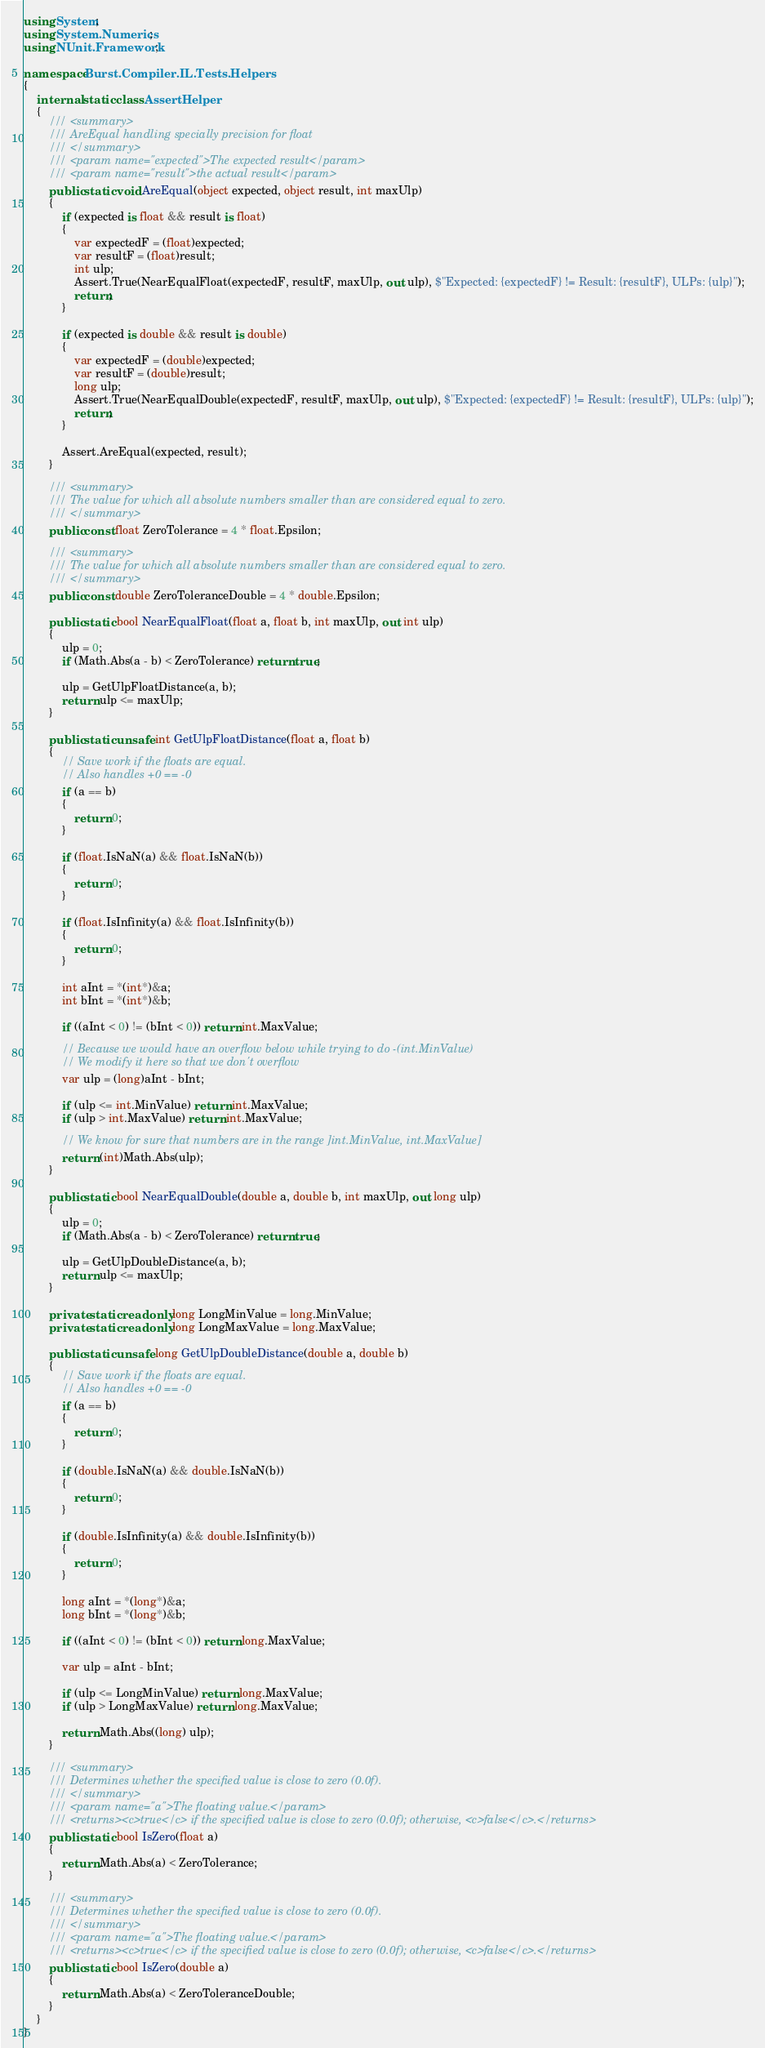<code> <loc_0><loc_0><loc_500><loc_500><_C#_>using System;
using System.Numerics;
using NUnit.Framework;

namespace Burst.Compiler.IL.Tests.Helpers
{
    internal static class AssertHelper
    {
        /// <summary>
        /// AreEqual handling specially precision for float
        /// </summary>
        /// <param name="expected">The expected result</param>
        /// <param name="result">the actual result</param>
        public static void AreEqual(object expected, object result, int maxUlp)
        {
            if (expected is float && result is float)
            {
                var expectedF = (float)expected;
                var resultF = (float)result;
                int ulp;
                Assert.True(NearEqualFloat(expectedF, resultF, maxUlp, out ulp), $"Expected: {expectedF} != Result: {resultF}, ULPs: {ulp}");
                return;
            }

            if (expected is double && result is double)
            {
                var expectedF = (double)expected;
                var resultF = (double)result;
                long ulp;
                Assert.True(NearEqualDouble(expectedF, resultF, maxUlp, out ulp), $"Expected: {expectedF} != Result: {resultF}, ULPs: {ulp}");
                return;
            }

            Assert.AreEqual(expected, result);
        }

        /// <summary>
        /// The value for which all absolute numbers smaller than are considered equal to zero.
        /// </summary>
        public const float ZeroTolerance = 4 * float.Epsilon;

        /// <summary>
        /// The value for which all absolute numbers smaller than are considered equal to zero.
        /// </summary>
        public const double ZeroToleranceDouble = 4 * double.Epsilon;

        public static bool NearEqualFloat(float a, float b, int maxUlp, out int ulp)
        {
            ulp = 0;
            if (Math.Abs(a - b) < ZeroTolerance) return true;

            ulp = GetUlpFloatDistance(a, b);
            return ulp <= maxUlp;
        }

        public static unsafe int GetUlpFloatDistance(float a, float b)
        {
            // Save work if the floats are equal.
            // Also handles +0 == -0
            if (a == b)
            {
                return 0;
            }

            if (float.IsNaN(a) && float.IsNaN(b))
            {
                return 0;
            }

            if (float.IsInfinity(a) && float.IsInfinity(b))
            {
                return 0;
            }

            int aInt = *(int*)&a;
            int bInt = *(int*)&b;

            if ((aInt < 0) != (bInt < 0)) return int.MaxValue;

            // Because we would have an overflow below while trying to do -(int.MinValue)
            // We modify it here so that we don't overflow
            var ulp = (long)aInt - bInt;

            if (ulp <= int.MinValue) return int.MaxValue;
            if (ulp > int.MaxValue) return int.MaxValue;

            // We know for sure that numbers are in the range ]int.MinValue, int.MaxValue]
            return (int)Math.Abs(ulp);
        }

        public static bool NearEqualDouble(double a, double b, int maxUlp, out long ulp)
        {
            ulp = 0;
            if (Math.Abs(a - b) < ZeroTolerance) return true;

            ulp = GetUlpDoubleDistance(a, b);
            return ulp <= maxUlp;
        }

        private static readonly long LongMinValue = long.MinValue;
        private static readonly long LongMaxValue = long.MaxValue;

        public static unsafe long GetUlpDoubleDistance(double a, double b)
        {
            // Save work if the floats are equal.
            // Also handles +0 == -0
            if (a == b)
            {
                return 0;
            }

            if (double.IsNaN(a) && double.IsNaN(b))
            {
                return 0;
            }

            if (double.IsInfinity(a) && double.IsInfinity(b))
            {
                return 0;
            }

            long aInt = *(long*)&a;
            long bInt = *(long*)&b;

            if ((aInt < 0) != (bInt < 0)) return long.MaxValue;

            var ulp = aInt - bInt;

            if (ulp <= LongMinValue) return long.MaxValue;
            if (ulp > LongMaxValue) return long.MaxValue;

            return Math.Abs((long) ulp);
        }

        /// <summary>
        /// Determines whether the specified value is close to zero (0.0f).
        /// </summary>
        /// <param name="a">The floating value.</param>
        /// <returns><c>true</c> if the specified value is close to zero (0.0f); otherwise, <c>false</c>.</returns>
        public static bool IsZero(float a)
        {
            return Math.Abs(a) < ZeroTolerance;
        }

        /// <summary>
        /// Determines whether the specified value is close to zero (0.0f).
        /// </summary>
        /// <param name="a">The floating value.</param>
        /// <returns><c>true</c> if the specified value is close to zero (0.0f); otherwise, <c>false</c>.</returns>
        public static bool IsZero(double a)
        {
            return Math.Abs(a) < ZeroToleranceDouble;
        }
    }
}</code> 